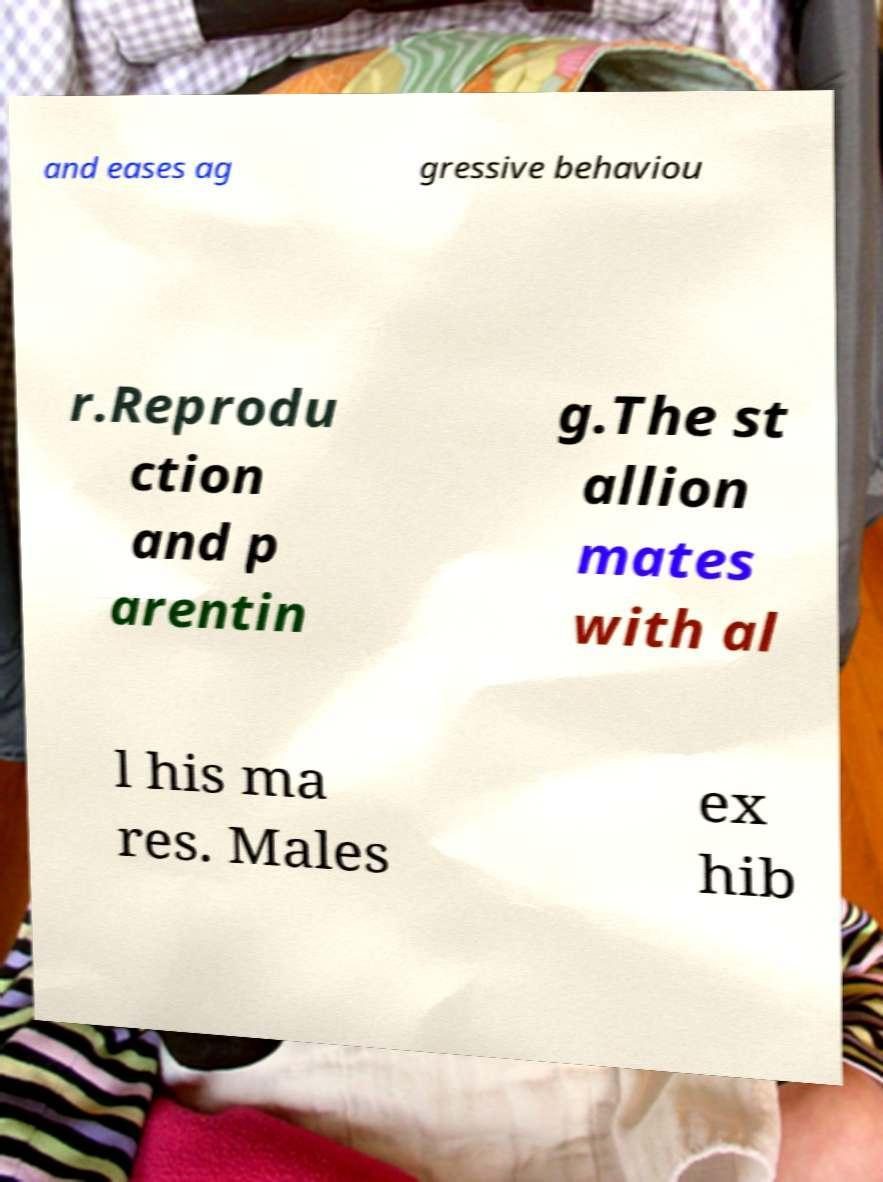Can you accurately transcribe the text from the provided image for me? and eases ag gressive behaviou r.Reprodu ction and p arentin g.The st allion mates with al l his ma res. Males ex hib 